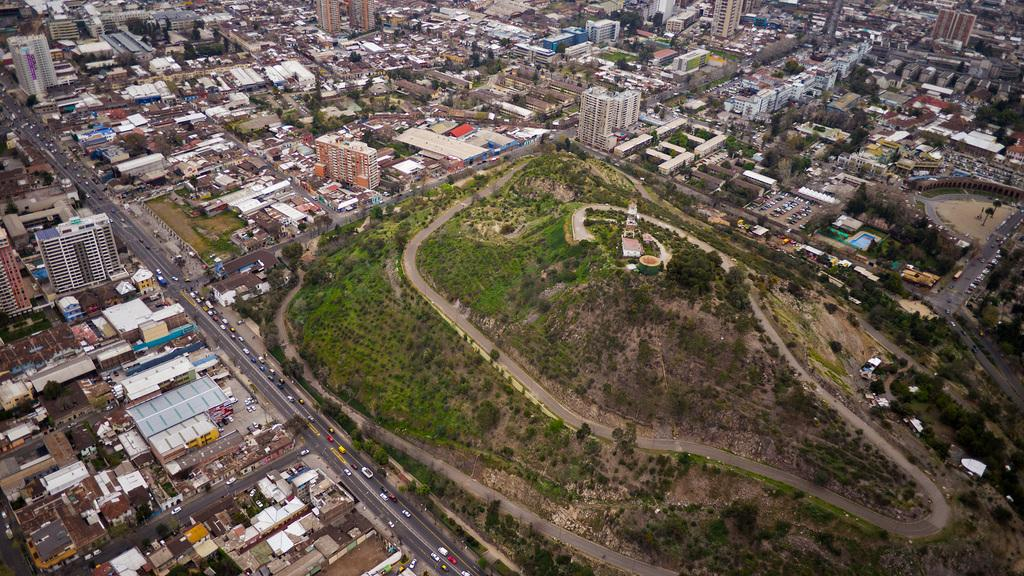What type of structures are located at the bottom of the image? There are buildings and houses at the bottom of the image. What can be seen running through the image? There is a road in the image. What is moving along the road in the image? Vehicles are present on the road. What natural elements are in the center of the image? There are trees in the center of the image. What pathway is in the center of the image? There is a walkway in the center of the image. Can you tell me how many clams are on the walkway in the image? There are no clams present in the image; it features a walkway surrounded by trees and vehicles on a road. What is the end of the image used for? The image does not have an "end" as it is a static representation, not a physical object with a specific purpose or function. 